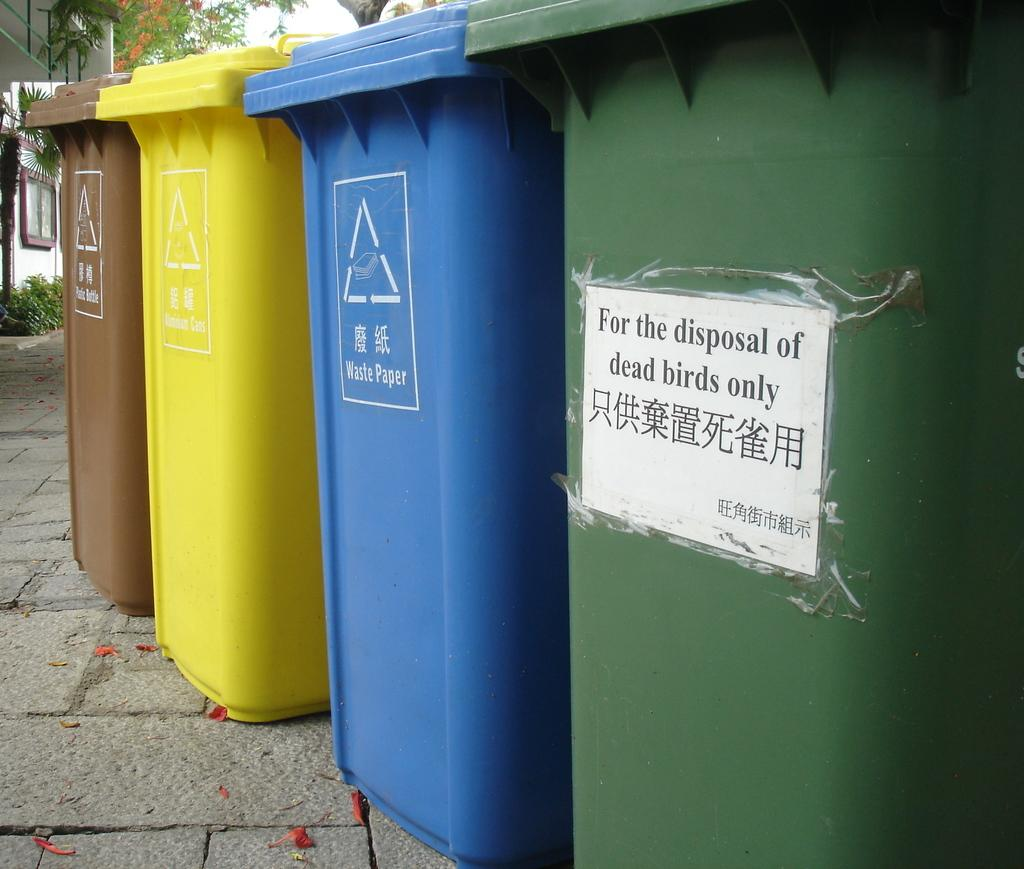<image>
Relay a brief, clear account of the picture shown. the four plastic rubbish bins are placed in the street and one of which has the writings of For the disposal of dead birds only. 